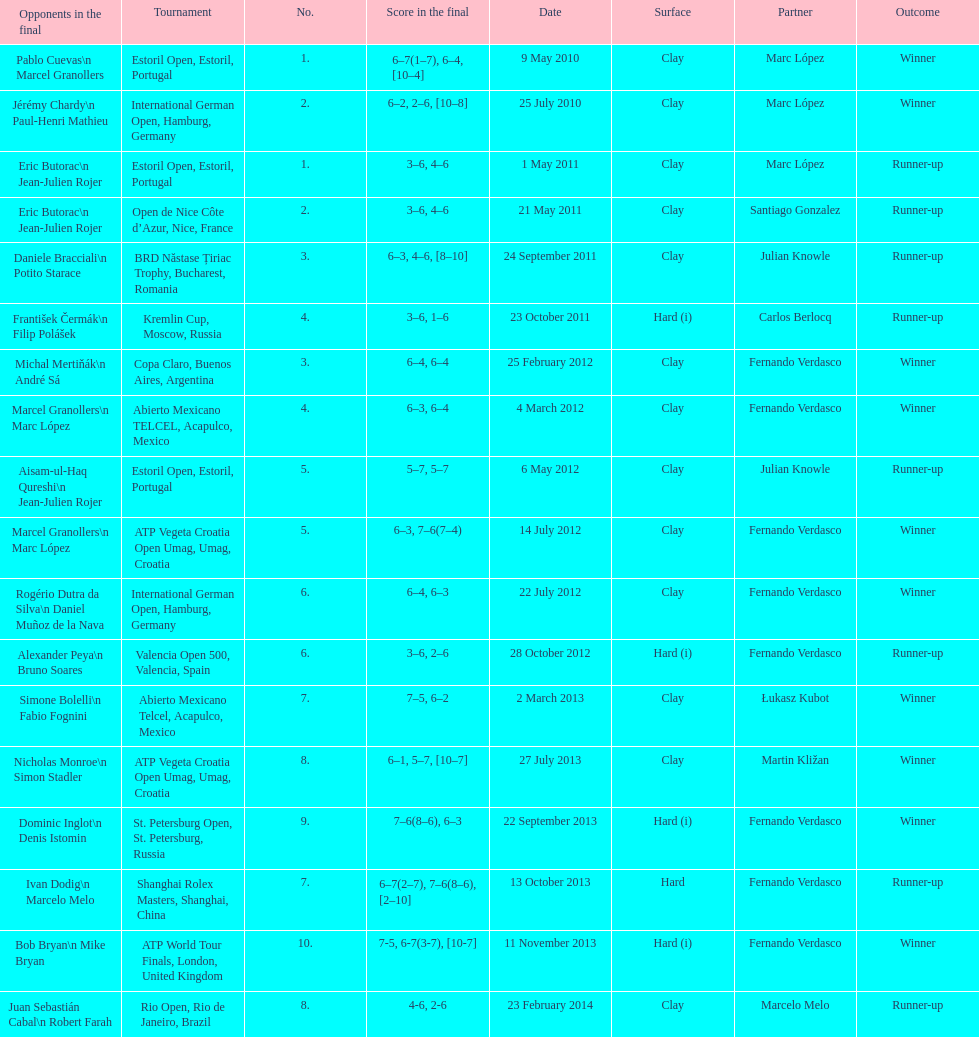What is the total number of runner-ups listed on the chart? 8. 